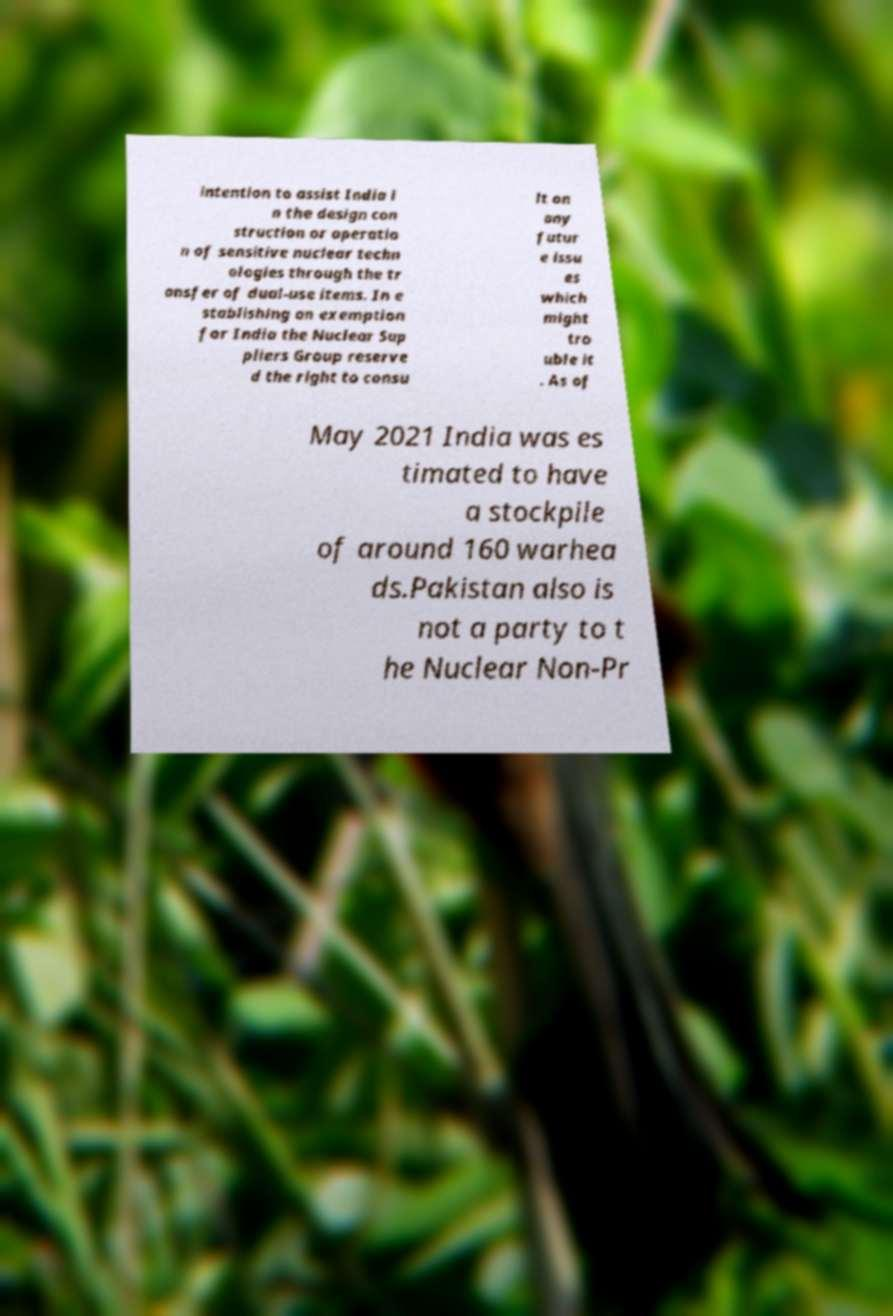Could you extract and type out the text from this image? intention to assist India i n the design con struction or operatio n of sensitive nuclear techn ologies through the tr ansfer of dual-use items. In e stablishing an exemption for India the Nuclear Sup pliers Group reserve d the right to consu lt on any futur e issu es which might tro uble it . As of May 2021 India was es timated to have a stockpile of around 160 warhea ds.Pakistan also is not a party to t he Nuclear Non-Pr 